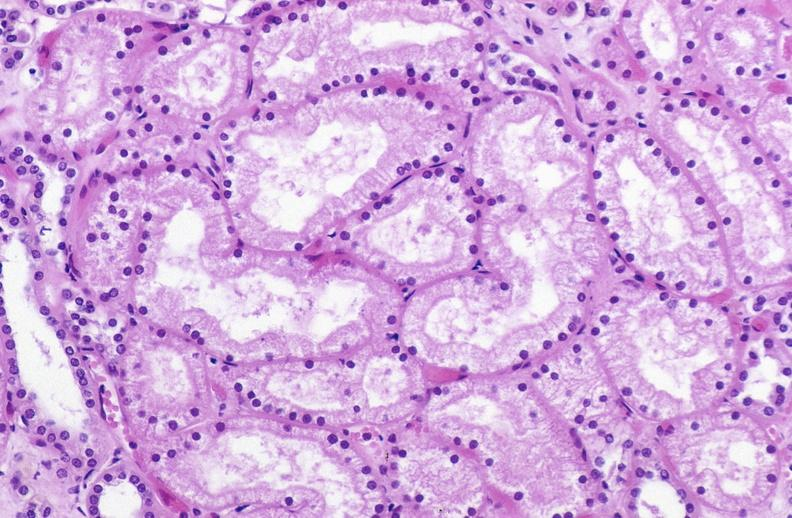s urinary present?
Answer the question using a single word or phrase. Yes 